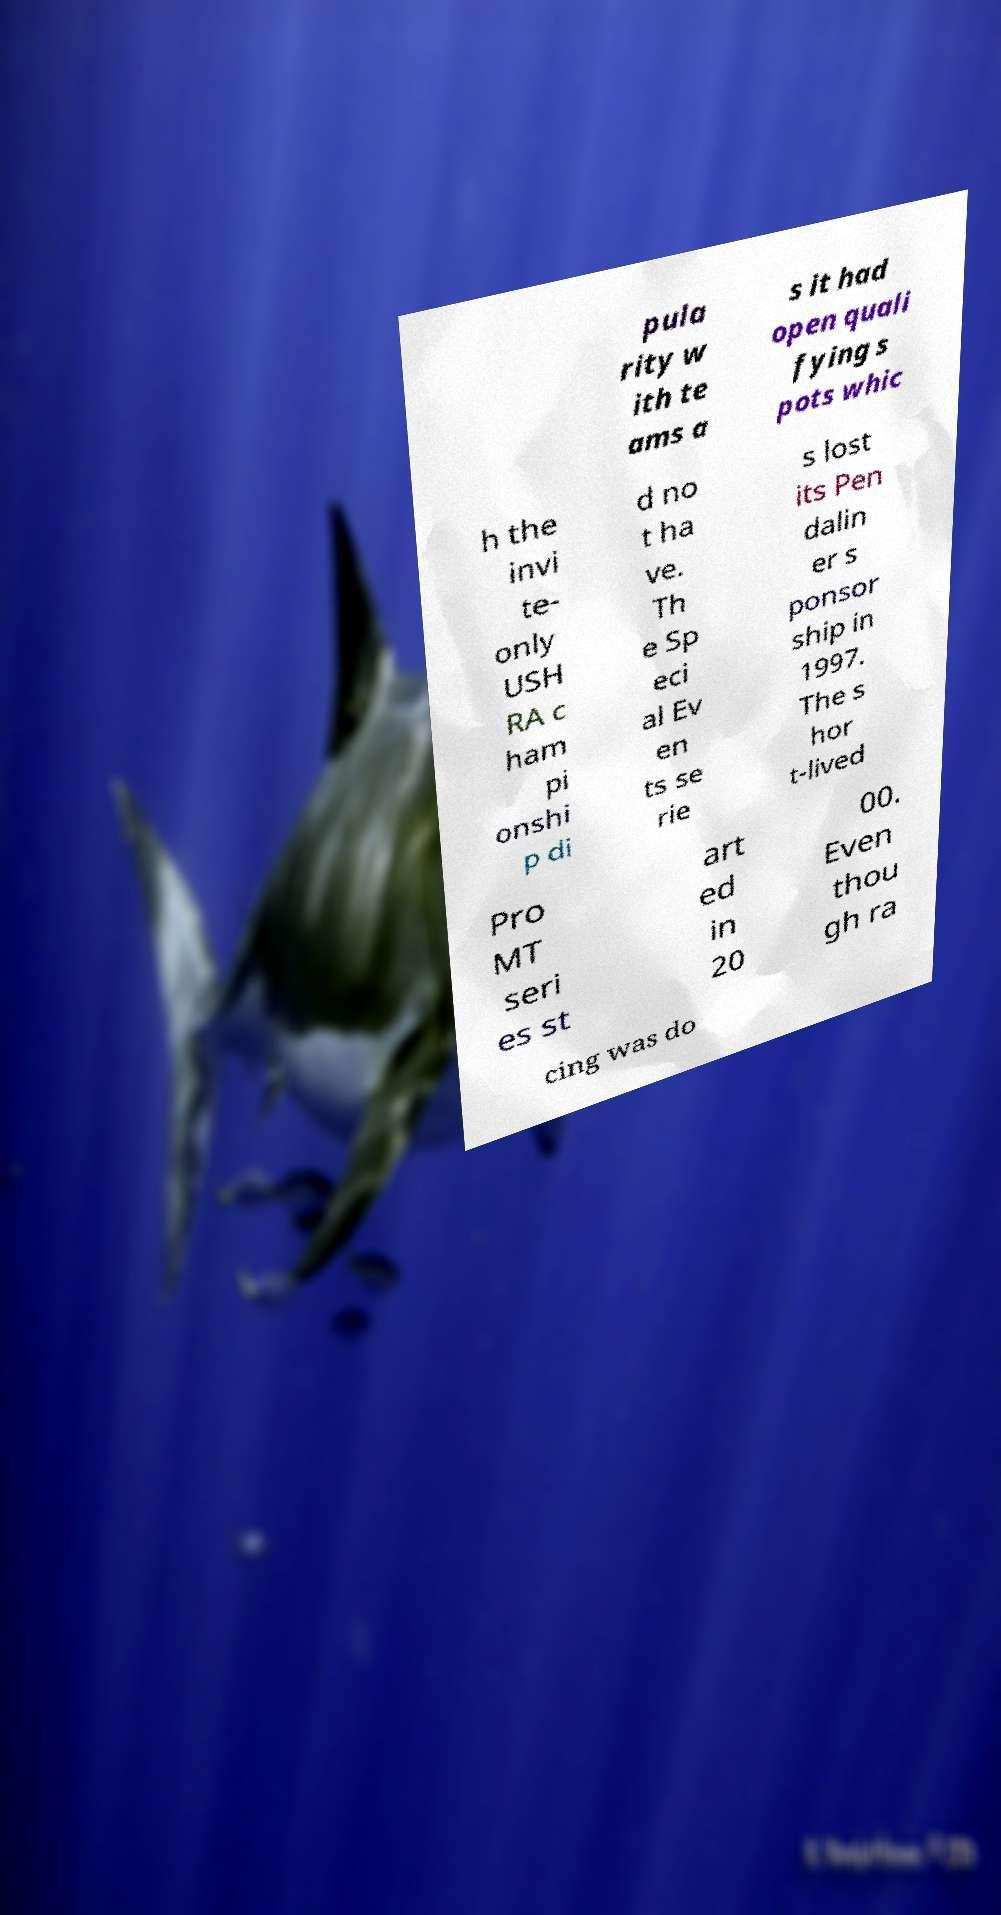For documentation purposes, I need the text within this image transcribed. Could you provide that? pula rity w ith te ams a s it had open quali fying s pots whic h the invi te- only USH RA c ham pi onshi p di d no t ha ve. Th e Sp eci al Ev en ts se rie s lost its Pen dalin er s ponsor ship in 1997. The s hor t-lived Pro MT seri es st art ed in 20 00. Even thou gh ra cing was do 